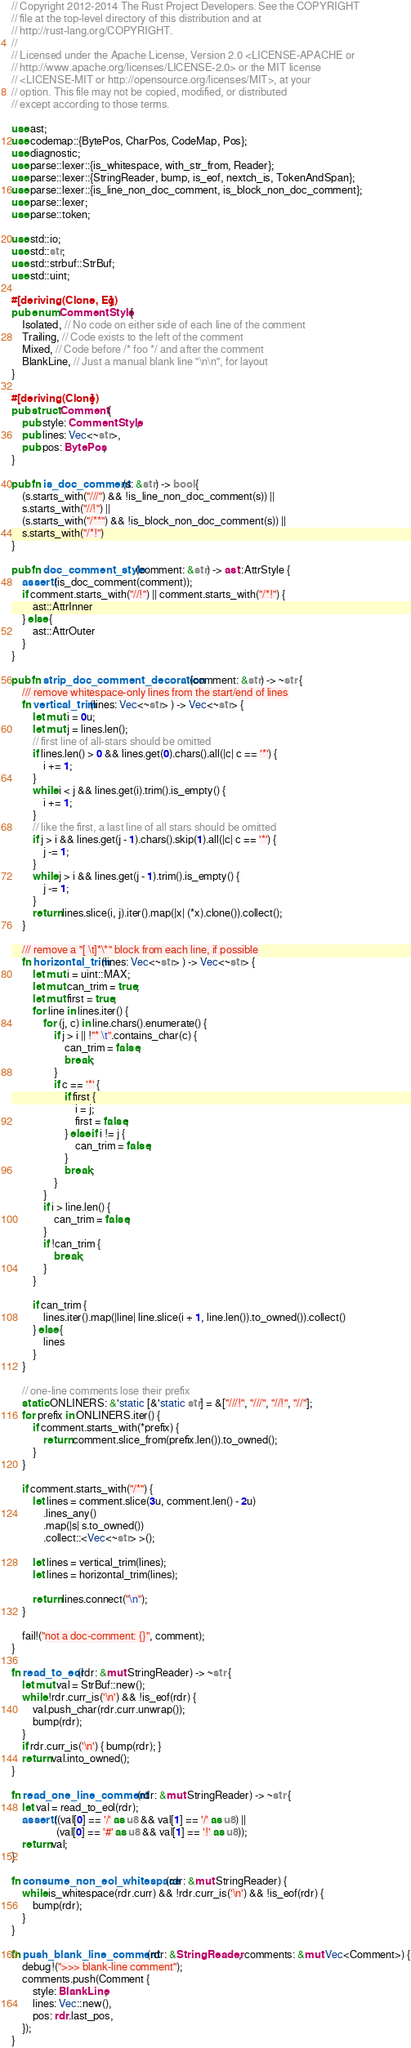<code> <loc_0><loc_0><loc_500><loc_500><_Rust_>// Copyright 2012-2014 The Rust Project Developers. See the COPYRIGHT
// file at the top-level directory of this distribution and at
// http://rust-lang.org/COPYRIGHT.
//
// Licensed under the Apache License, Version 2.0 <LICENSE-APACHE or
// http://www.apache.org/licenses/LICENSE-2.0> or the MIT license
// <LICENSE-MIT or http://opensource.org/licenses/MIT>, at your
// option. This file may not be copied, modified, or distributed
// except according to those terms.

use ast;
use codemap::{BytePos, CharPos, CodeMap, Pos};
use diagnostic;
use parse::lexer::{is_whitespace, with_str_from, Reader};
use parse::lexer::{StringReader, bump, is_eof, nextch_is, TokenAndSpan};
use parse::lexer::{is_line_non_doc_comment, is_block_non_doc_comment};
use parse::lexer;
use parse::token;

use std::io;
use std::str;
use std::strbuf::StrBuf;
use std::uint;

#[deriving(Clone, Eq)]
pub enum CommentStyle {
    Isolated, // No code on either side of each line of the comment
    Trailing, // Code exists to the left of the comment
    Mixed, // Code before /* foo */ and after the comment
    BlankLine, // Just a manual blank line "\n\n", for layout
}

#[deriving(Clone)]
pub struct Comment {
    pub style: CommentStyle,
    pub lines: Vec<~str>,
    pub pos: BytePos,
}

pub fn is_doc_comment(s: &str) -> bool {
    (s.starts_with("///") && !is_line_non_doc_comment(s)) ||
    s.starts_with("//!") ||
    (s.starts_with("/**") && !is_block_non_doc_comment(s)) ||
    s.starts_with("/*!")
}

pub fn doc_comment_style(comment: &str) -> ast::AttrStyle {
    assert!(is_doc_comment(comment));
    if comment.starts_with("//!") || comment.starts_with("/*!") {
        ast::AttrInner
    } else {
        ast::AttrOuter
    }
}

pub fn strip_doc_comment_decoration(comment: &str) -> ~str {
    /// remove whitespace-only lines from the start/end of lines
    fn vertical_trim(lines: Vec<~str> ) -> Vec<~str> {
        let mut i = 0u;
        let mut j = lines.len();
        // first line of all-stars should be omitted
        if lines.len() > 0 && lines.get(0).chars().all(|c| c == '*') {
            i += 1;
        }
        while i < j && lines.get(i).trim().is_empty() {
            i += 1;
        }
        // like the first, a last line of all stars should be omitted
        if j > i && lines.get(j - 1).chars().skip(1).all(|c| c == '*') {
            j -= 1;
        }
        while j > i && lines.get(j - 1).trim().is_empty() {
            j -= 1;
        }
        return lines.slice(i, j).iter().map(|x| (*x).clone()).collect();
    }

    /// remove a "[ \t]*\*" block from each line, if possible
    fn horizontal_trim(lines: Vec<~str> ) -> Vec<~str> {
        let mut i = uint::MAX;
        let mut can_trim = true;
        let mut first = true;
        for line in lines.iter() {
            for (j, c) in line.chars().enumerate() {
                if j > i || !"* \t".contains_char(c) {
                    can_trim = false;
                    break;
                }
                if c == '*' {
                    if first {
                        i = j;
                        first = false;
                    } else if i != j {
                        can_trim = false;
                    }
                    break;
                }
            }
            if i > line.len() {
                can_trim = false;
            }
            if !can_trim {
                break;
            }
        }

        if can_trim {
            lines.iter().map(|line| line.slice(i + 1, line.len()).to_owned()).collect()
        } else {
            lines
        }
    }

    // one-line comments lose their prefix
    static ONLINERS: &'static [&'static str] = &["///!", "///", "//!", "//"];
    for prefix in ONLINERS.iter() {
        if comment.starts_with(*prefix) {
            return comment.slice_from(prefix.len()).to_owned();
        }
    }

    if comment.starts_with("/*") {
        let lines = comment.slice(3u, comment.len() - 2u)
            .lines_any()
            .map(|s| s.to_owned())
            .collect::<Vec<~str> >();

        let lines = vertical_trim(lines);
        let lines = horizontal_trim(lines);

        return lines.connect("\n");
    }

    fail!("not a doc-comment: {}", comment);
}

fn read_to_eol(rdr: &mut StringReader) -> ~str {
    let mut val = StrBuf::new();
    while !rdr.curr_is('\n') && !is_eof(rdr) {
        val.push_char(rdr.curr.unwrap());
        bump(rdr);
    }
    if rdr.curr_is('\n') { bump(rdr); }
    return val.into_owned();
}

fn read_one_line_comment(rdr: &mut StringReader) -> ~str {
    let val = read_to_eol(rdr);
    assert!((val[0] == '/' as u8 && val[1] == '/' as u8) ||
                 (val[0] == '#' as u8 && val[1] == '!' as u8));
    return val;
}

fn consume_non_eol_whitespace(rdr: &mut StringReader) {
    while is_whitespace(rdr.curr) && !rdr.curr_is('\n') && !is_eof(rdr) {
        bump(rdr);
    }
}

fn push_blank_line_comment(rdr: &StringReader, comments: &mut Vec<Comment>) {
    debug!(">>> blank-line comment");
    comments.push(Comment {
        style: BlankLine,
        lines: Vec::new(),
        pos: rdr.last_pos,
    });
}
</code> 